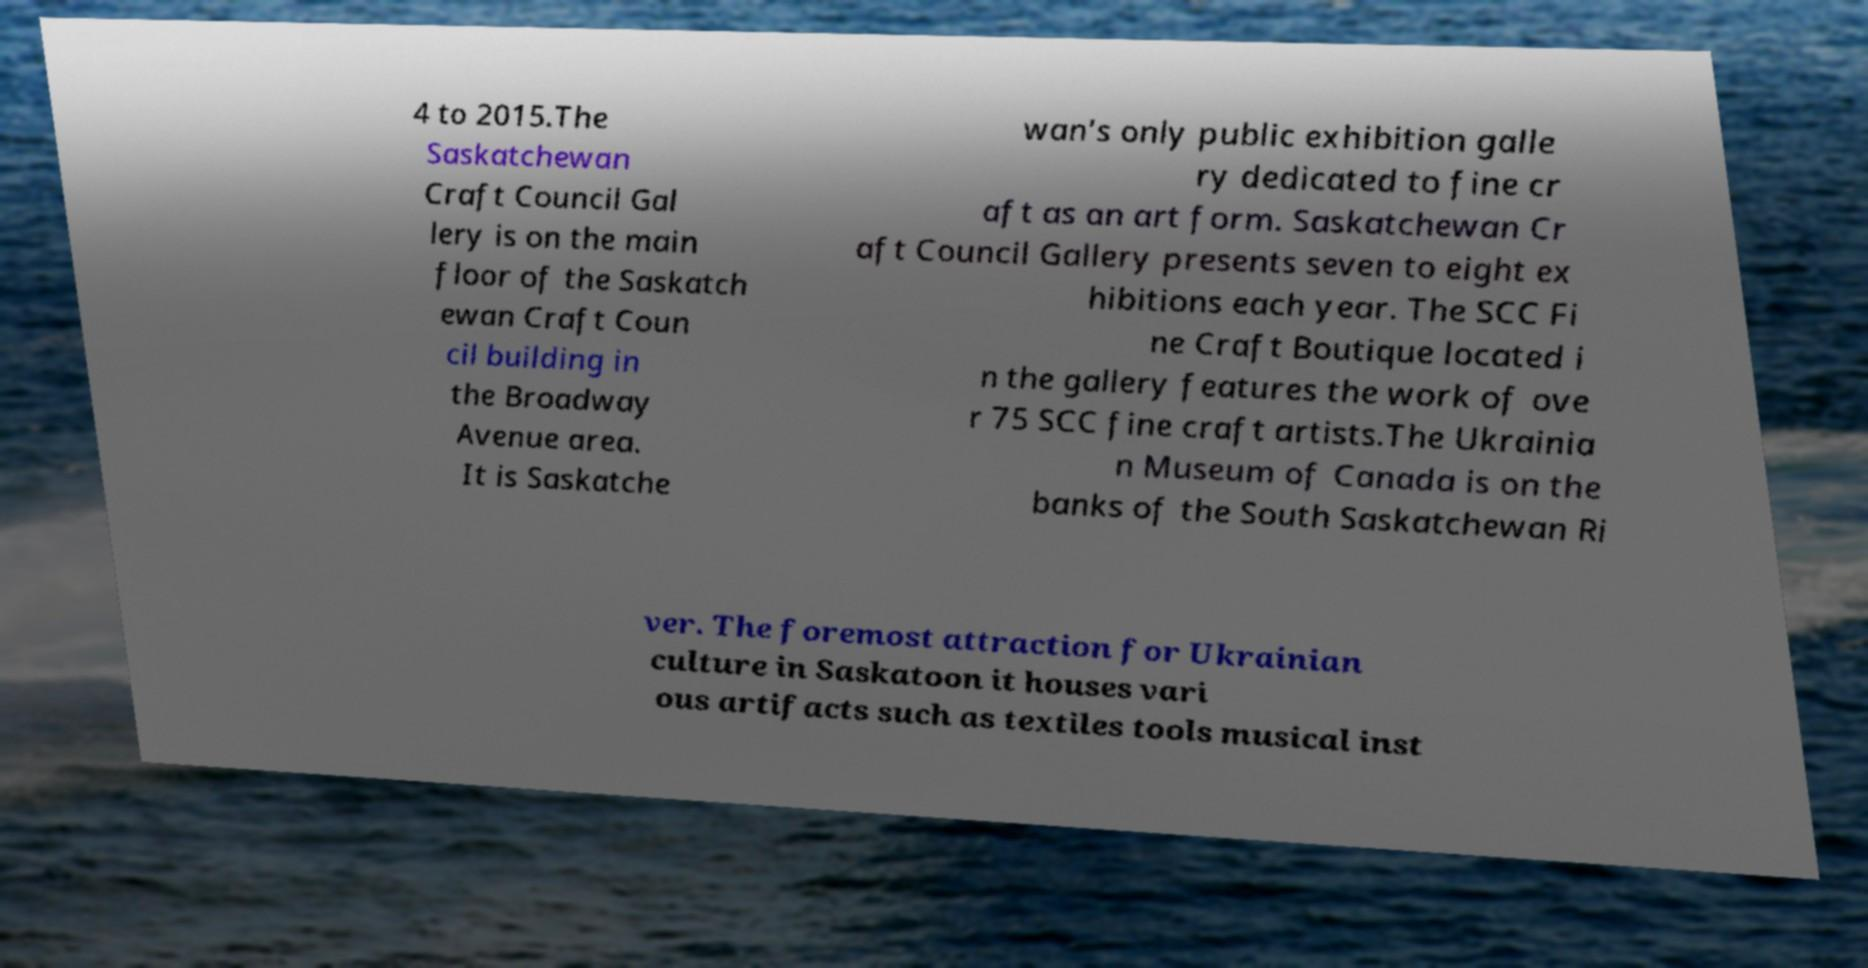There's text embedded in this image that I need extracted. Can you transcribe it verbatim? 4 to 2015.The Saskatchewan Craft Council Gal lery is on the main floor of the Saskatch ewan Craft Coun cil building in the Broadway Avenue area. It is Saskatche wan's only public exhibition galle ry dedicated to fine cr aft as an art form. Saskatchewan Cr aft Council Gallery presents seven to eight ex hibitions each year. The SCC Fi ne Craft Boutique located i n the gallery features the work of ove r 75 SCC fine craft artists.The Ukrainia n Museum of Canada is on the banks of the South Saskatchewan Ri ver. The foremost attraction for Ukrainian culture in Saskatoon it houses vari ous artifacts such as textiles tools musical inst 